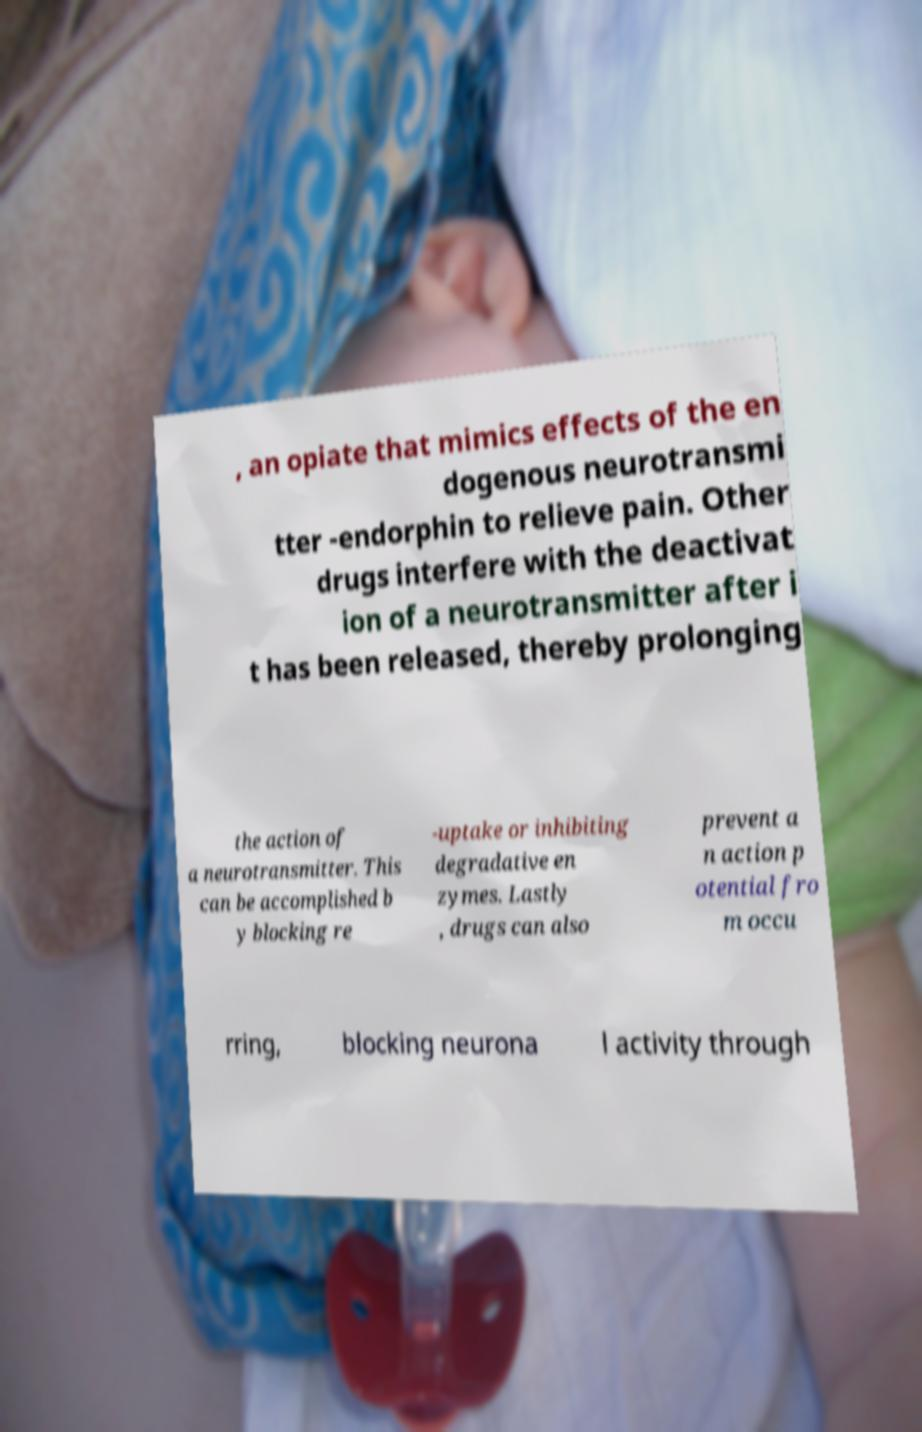Could you assist in decoding the text presented in this image and type it out clearly? , an opiate that mimics effects of the en dogenous neurotransmi tter -endorphin to relieve pain. Other drugs interfere with the deactivat ion of a neurotransmitter after i t has been released, thereby prolonging the action of a neurotransmitter. This can be accomplished b y blocking re -uptake or inhibiting degradative en zymes. Lastly , drugs can also prevent a n action p otential fro m occu rring, blocking neurona l activity through 